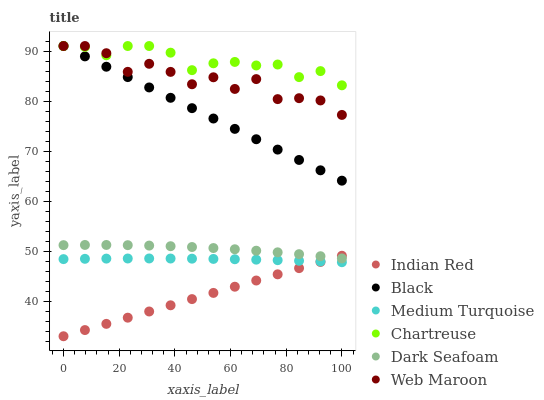Does Indian Red have the minimum area under the curve?
Answer yes or no. Yes. Does Chartreuse have the maximum area under the curve?
Answer yes or no. Yes. Does Web Maroon have the minimum area under the curve?
Answer yes or no. No. Does Web Maroon have the maximum area under the curve?
Answer yes or no. No. Is Indian Red the smoothest?
Answer yes or no. Yes. Is Web Maroon the roughest?
Answer yes or no. Yes. Is Chartreuse the smoothest?
Answer yes or no. No. Is Chartreuse the roughest?
Answer yes or no. No. Does Indian Red have the lowest value?
Answer yes or no. Yes. Does Web Maroon have the lowest value?
Answer yes or no. No. Does Black have the highest value?
Answer yes or no. Yes. Does Dark Seafoam have the highest value?
Answer yes or no. No. Is Dark Seafoam less than Black?
Answer yes or no. Yes. Is Web Maroon greater than Medium Turquoise?
Answer yes or no. Yes. Does Web Maroon intersect Chartreuse?
Answer yes or no. Yes. Is Web Maroon less than Chartreuse?
Answer yes or no. No. Is Web Maroon greater than Chartreuse?
Answer yes or no. No. Does Dark Seafoam intersect Black?
Answer yes or no. No. 